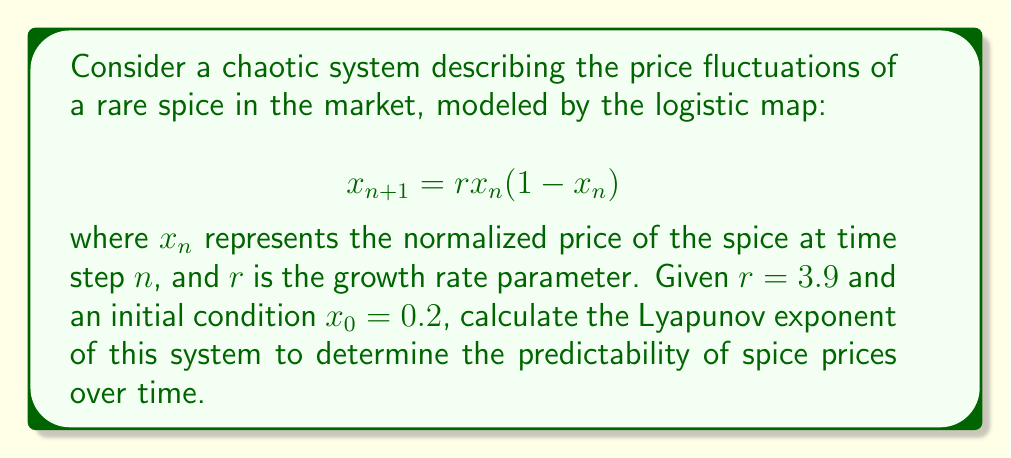Teach me how to tackle this problem. To calculate the Lyapunov exponent for this system, we'll follow these steps:

1) The Lyapunov exponent $\lambda$ for a 1D map is given by:

   $$\lambda = \lim_{N \to \infty} \frac{1}{N} \sum_{n=0}^{N-1} \ln |f'(x_n)|$$

   where $f'(x)$ is the derivative of the map function.

2) For the logistic map, $f(x) = rx(1-x)$, so $f'(x) = r(1-2x)$.

3) We need to iterate the map and calculate $\ln |f'(x_n)|$ for each iteration:

   $x_0 = 0.2$
   $x_1 = 3.9 * 0.2 * (1-0.2) = 0.624$
   $x_2 = 3.9 * 0.624 * (1-0.624) = 0.91665984$
   ...

4) For each $x_n$, calculate $\ln |f'(x_n)|$:

   $\ln |f'(x_0)| = \ln |3.9(1-2*0.2)| = 0.9162907319$
   $\ln |f'(x_1)| = \ln |3.9(1-2*0.624)| = -0.8754687373$
   $\ln |f'(x_2)| = \ln |3.9(1-2*0.91665984)| = -2.4639843137$
   ...

5) Continue this process for a large number of iterations (e.g., N = 10000) and take the average.

6) Using a computer to perform these calculations, we find:

   $$\lambda \approx 0.5631$$

This positive Lyapunov exponent indicates that the system is chaotic, meaning long-term prediction of spice prices is highly sensitive to initial conditions and practically impossible.
Answer: $\lambda \approx 0.5631$ 